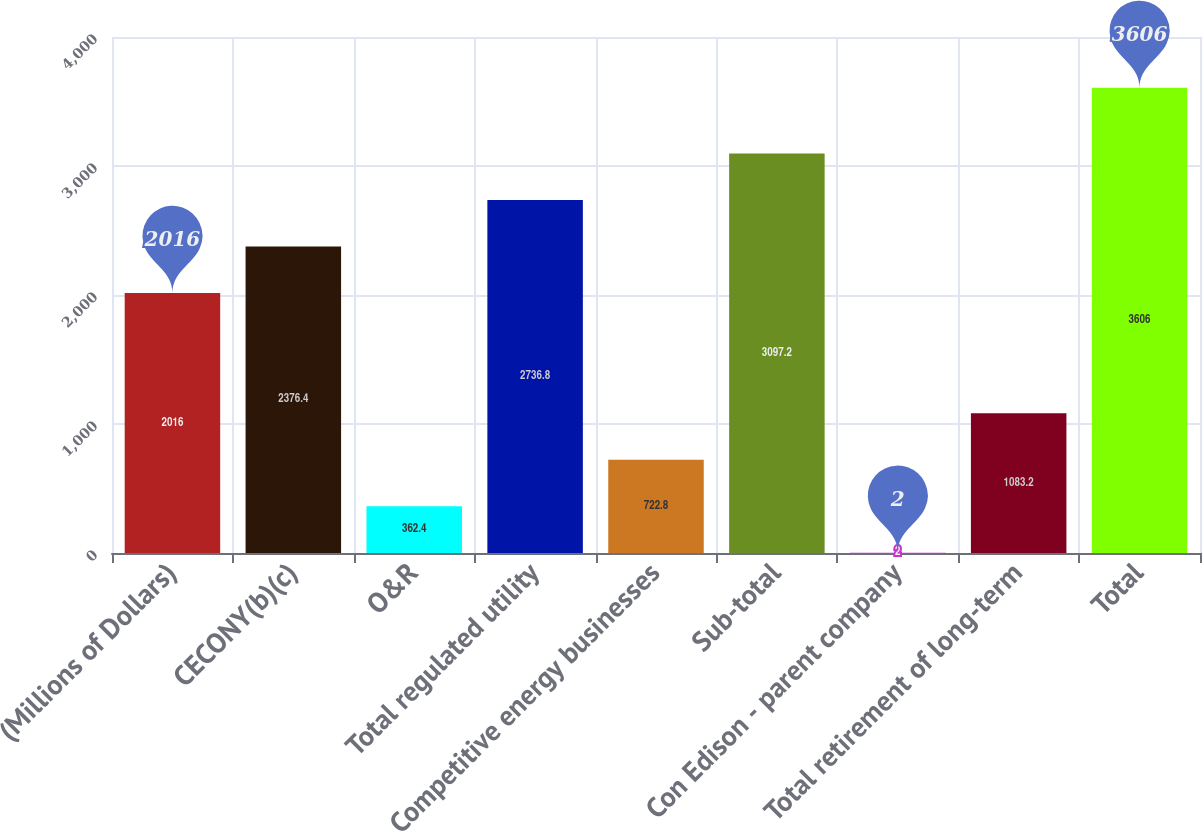<chart> <loc_0><loc_0><loc_500><loc_500><bar_chart><fcel>(Millions of Dollars)<fcel>CECONY(b)(c)<fcel>O&R<fcel>Total regulated utility<fcel>Competitive energy businesses<fcel>Sub-total<fcel>Con Edison - parent company<fcel>Total retirement of long-term<fcel>Total<nl><fcel>2016<fcel>2376.4<fcel>362.4<fcel>2736.8<fcel>722.8<fcel>3097.2<fcel>2<fcel>1083.2<fcel>3606<nl></chart> 